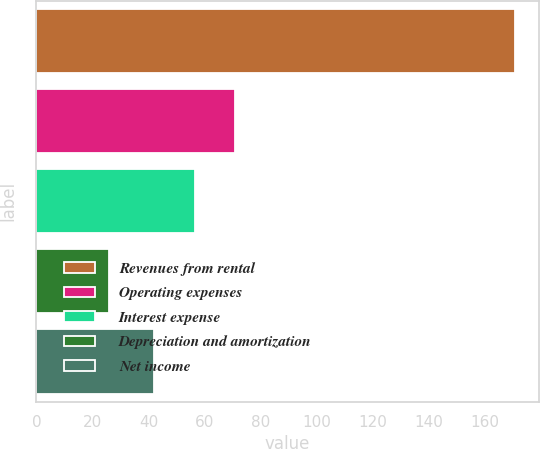Convert chart to OTSL. <chart><loc_0><loc_0><loc_500><loc_500><bar_chart><fcel>Revenues from rental<fcel>Operating expenses<fcel>Interest expense<fcel>Depreciation and amortization<fcel>Net income<nl><fcel>170.6<fcel>70.92<fcel>56.46<fcel>26<fcel>42<nl></chart> 